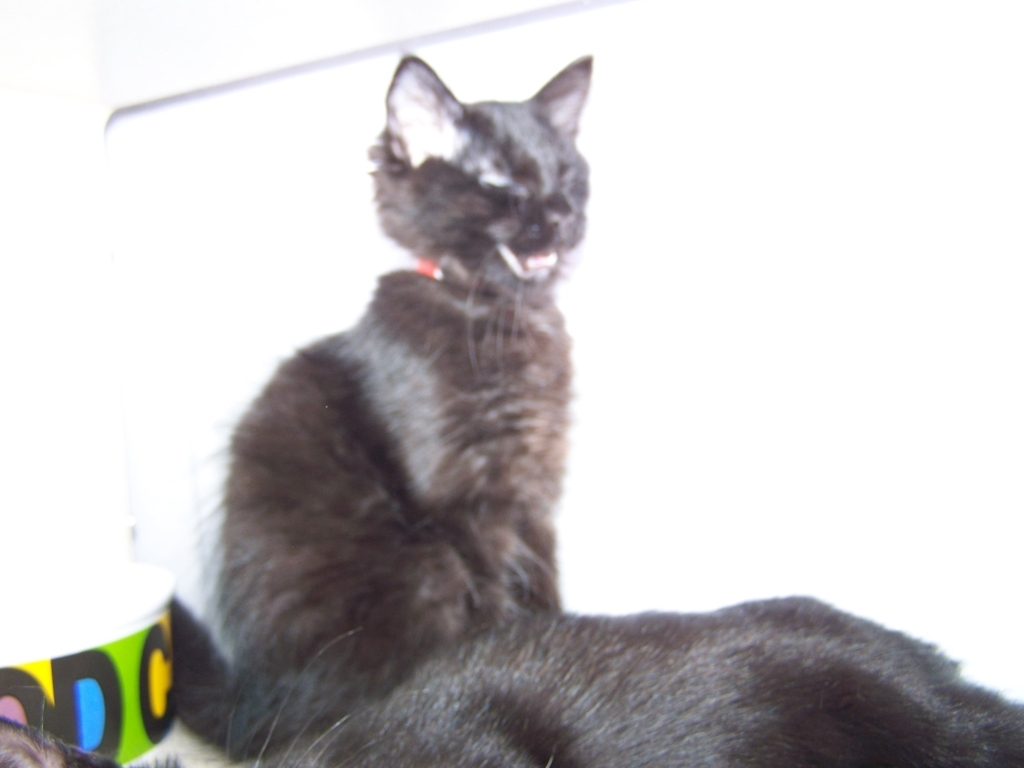What emotions might this cat be expressing? Although the image is not clear, the cat's half-closed eyes and the position of its mouth, which appears slightly open, might suggest a state of relaxation or mid-grooming. Keep in mind that interpreting a cat's emotions visually can be subjective, especially in an unclear photo. 